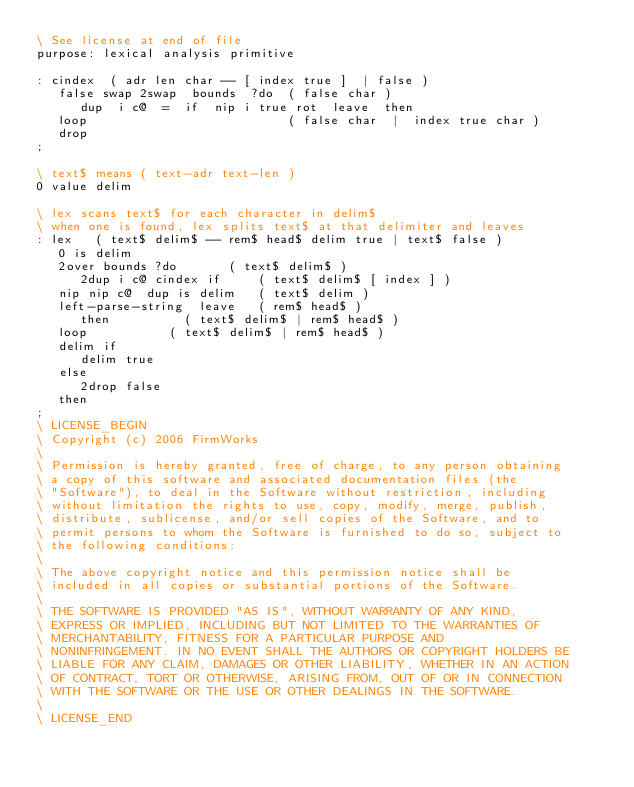Convert code to text. <code><loc_0><loc_0><loc_500><loc_500><_Forth_>\ See license at end of file
purpose: lexical analysis primitive

: cindex  ( adr len char -- [ index true ]  | false )
   false swap 2swap  bounds  ?do  ( false char )
      dup  i c@  =  if  nip i true rot  leave  then
   loop                           ( false char  |  index true char )
   drop
;

\ text$ means ( text-adr text-len )
0 value delim

\ lex scans text$ for each character in delim$
\ when one is found, lex splits text$ at that delimiter and leaves
: lex   ( text$ delim$ -- rem$ head$ delim true | text$ false )
   0 is delim
   2over bounds ?do				( text$ delim$ )
      2dup i c@ cindex if			( text$ delim$ [ index ] )
	 nip nip c@  dup is delim		( text$ delim )
	 left-parse-string  leave		( rem$ head$ )
      then					( text$ delim$ | rem$ head$ )
   loop						( text$ delim$ | rem$ head$ )
   delim if
      delim true
   else
      2drop false
   then
;
\ LICENSE_BEGIN
\ Copyright (c) 2006 FirmWorks
\ 
\ Permission is hereby granted, free of charge, to any person obtaining
\ a copy of this software and associated documentation files (the
\ "Software"), to deal in the Software without restriction, including
\ without limitation the rights to use, copy, modify, merge, publish,
\ distribute, sublicense, and/or sell copies of the Software, and to
\ permit persons to whom the Software is furnished to do so, subject to
\ the following conditions:
\ 
\ The above copyright notice and this permission notice shall be
\ included in all copies or substantial portions of the Software.
\ 
\ THE SOFTWARE IS PROVIDED "AS IS", WITHOUT WARRANTY OF ANY KIND,
\ EXPRESS OR IMPLIED, INCLUDING BUT NOT LIMITED TO THE WARRANTIES OF
\ MERCHANTABILITY, FITNESS FOR A PARTICULAR PURPOSE AND
\ NONINFRINGEMENT. IN NO EVENT SHALL THE AUTHORS OR COPYRIGHT HOLDERS BE
\ LIABLE FOR ANY CLAIM, DAMAGES OR OTHER LIABILITY, WHETHER IN AN ACTION
\ OF CONTRACT, TORT OR OTHERWISE, ARISING FROM, OUT OF OR IN CONNECTION
\ WITH THE SOFTWARE OR THE USE OR OTHER DEALINGS IN THE SOFTWARE.
\
\ LICENSE_END
</code> 